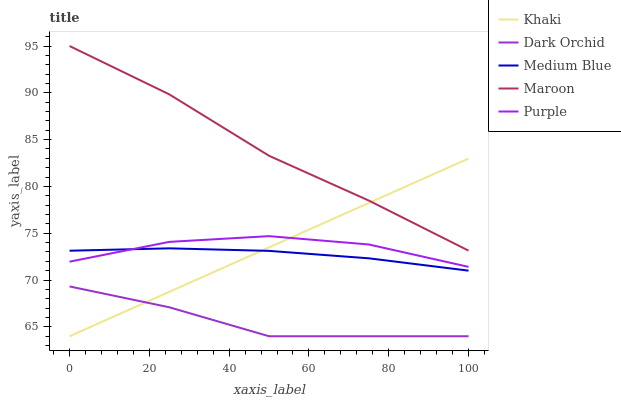Does Dark Orchid have the minimum area under the curve?
Answer yes or no. Yes. Does Maroon have the maximum area under the curve?
Answer yes or no. Yes. Does Khaki have the minimum area under the curve?
Answer yes or no. No. Does Khaki have the maximum area under the curve?
Answer yes or no. No. Is Khaki the smoothest?
Answer yes or no. Yes. Is Purple the roughest?
Answer yes or no. Yes. Is Medium Blue the smoothest?
Answer yes or no. No. Is Medium Blue the roughest?
Answer yes or no. No. Does Khaki have the lowest value?
Answer yes or no. Yes. Does Medium Blue have the lowest value?
Answer yes or no. No. Does Maroon have the highest value?
Answer yes or no. Yes. Does Khaki have the highest value?
Answer yes or no. No. Is Dark Orchid less than Medium Blue?
Answer yes or no. Yes. Is Purple greater than Dark Orchid?
Answer yes or no. Yes. Does Maroon intersect Khaki?
Answer yes or no. Yes. Is Maroon less than Khaki?
Answer yes or no. No. Is Maroon greater than Khaki?
Answer yes or no. No. Does Dark Orchid intersect Medium Blue?
Answer yes or no. No. 